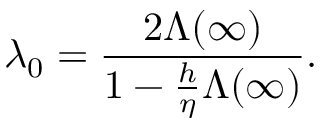Convert formula to latex. <formula><loc_0><loc_0><loc_500><loc_500>\lambda _ { 0 } = \frac { 2 \Lambda ( \infty ) } { 1 - \frac { h } { \eta } \Lambda ( \infty ) } .</formula> 